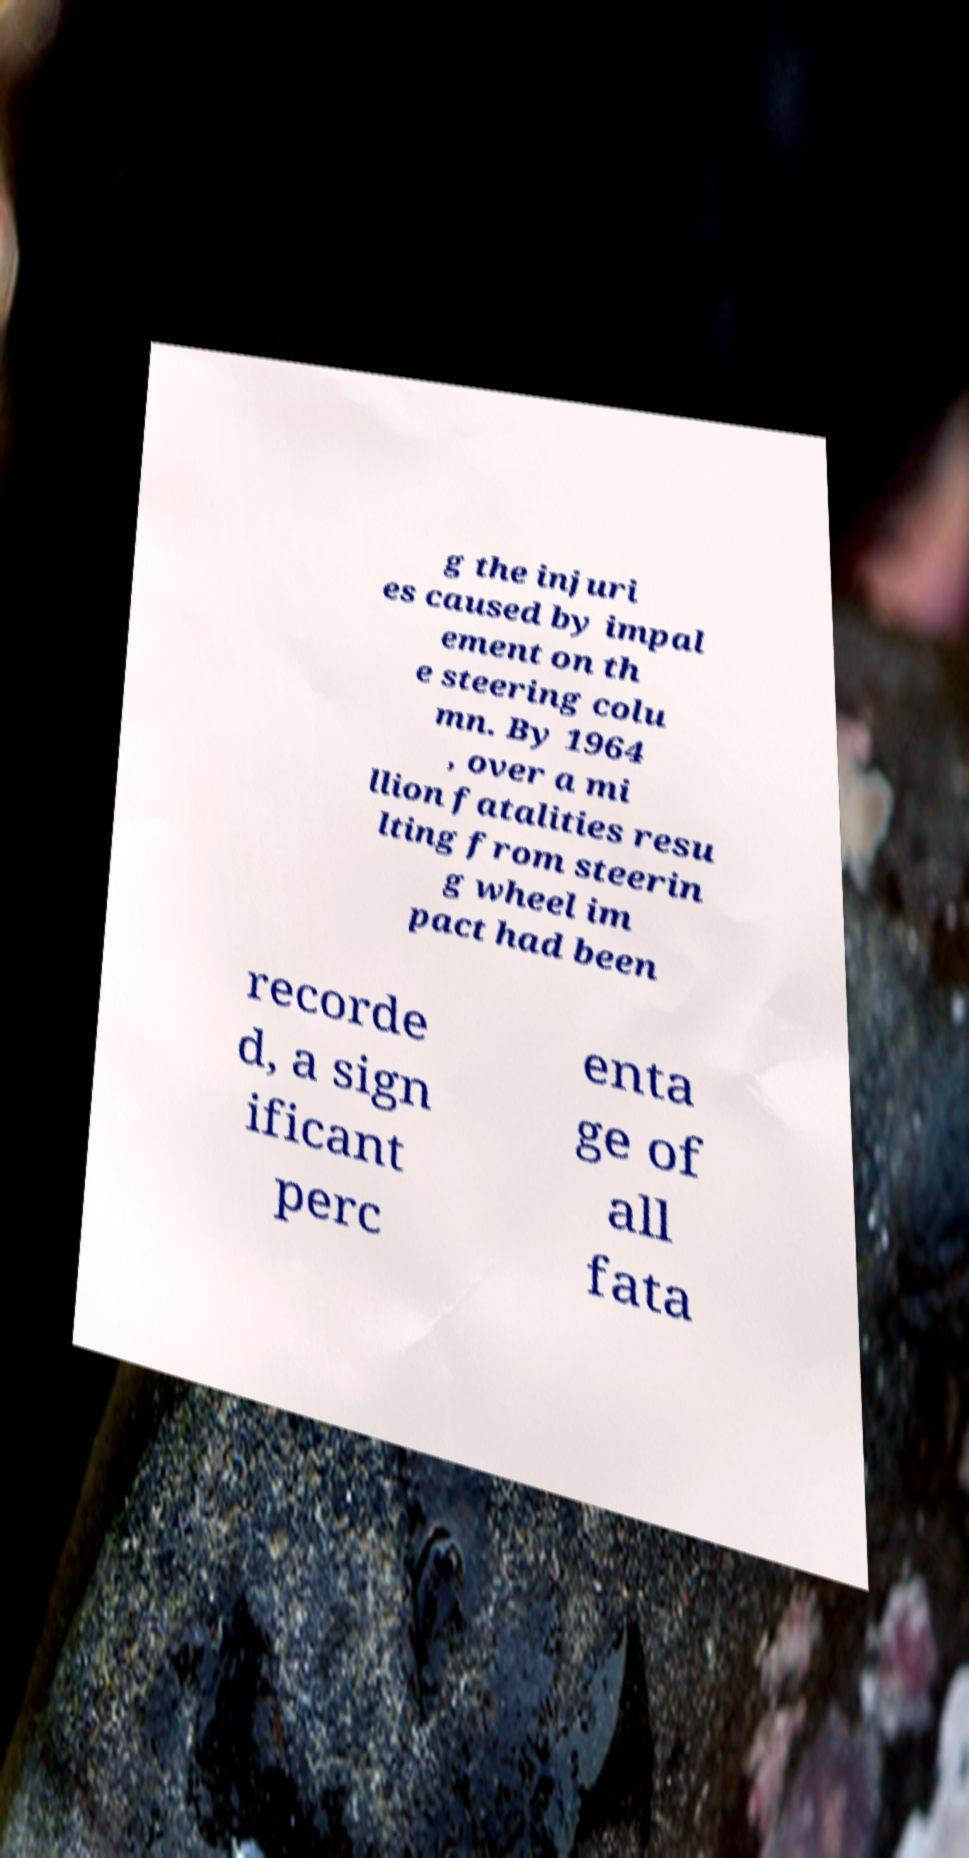Could you assist in decoding the text presented in this image and type it out clearly? g the injuri es caused by impal ement on th e steering colu mn. By 1964 , over a mi llion fatalities resu lting from steerin g wheel im pact had been recorde d, a sign ificant perc enta ge of all fata 